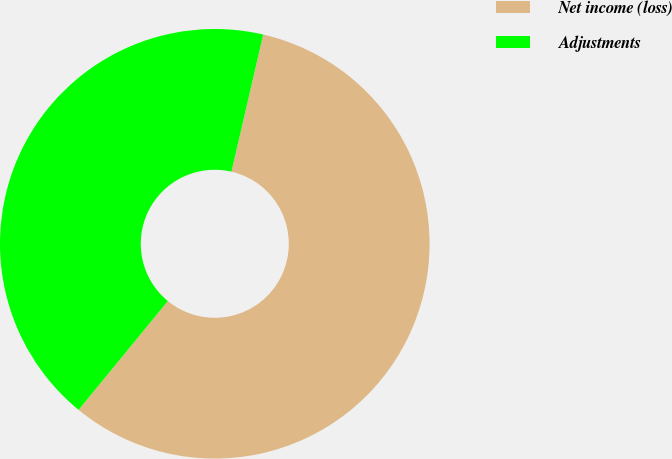Convert chart. <chart><loc_0><loc_0><loc_500><loc_500><pie_chart><fcel>Net income (loss)<fcel>Adjustments<nl><fcel>57.31%<fcel>42.69%<nl></chart> 